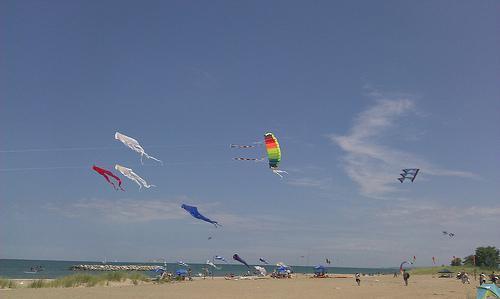How many kites are orange?
Give a very brief answer. 0. 